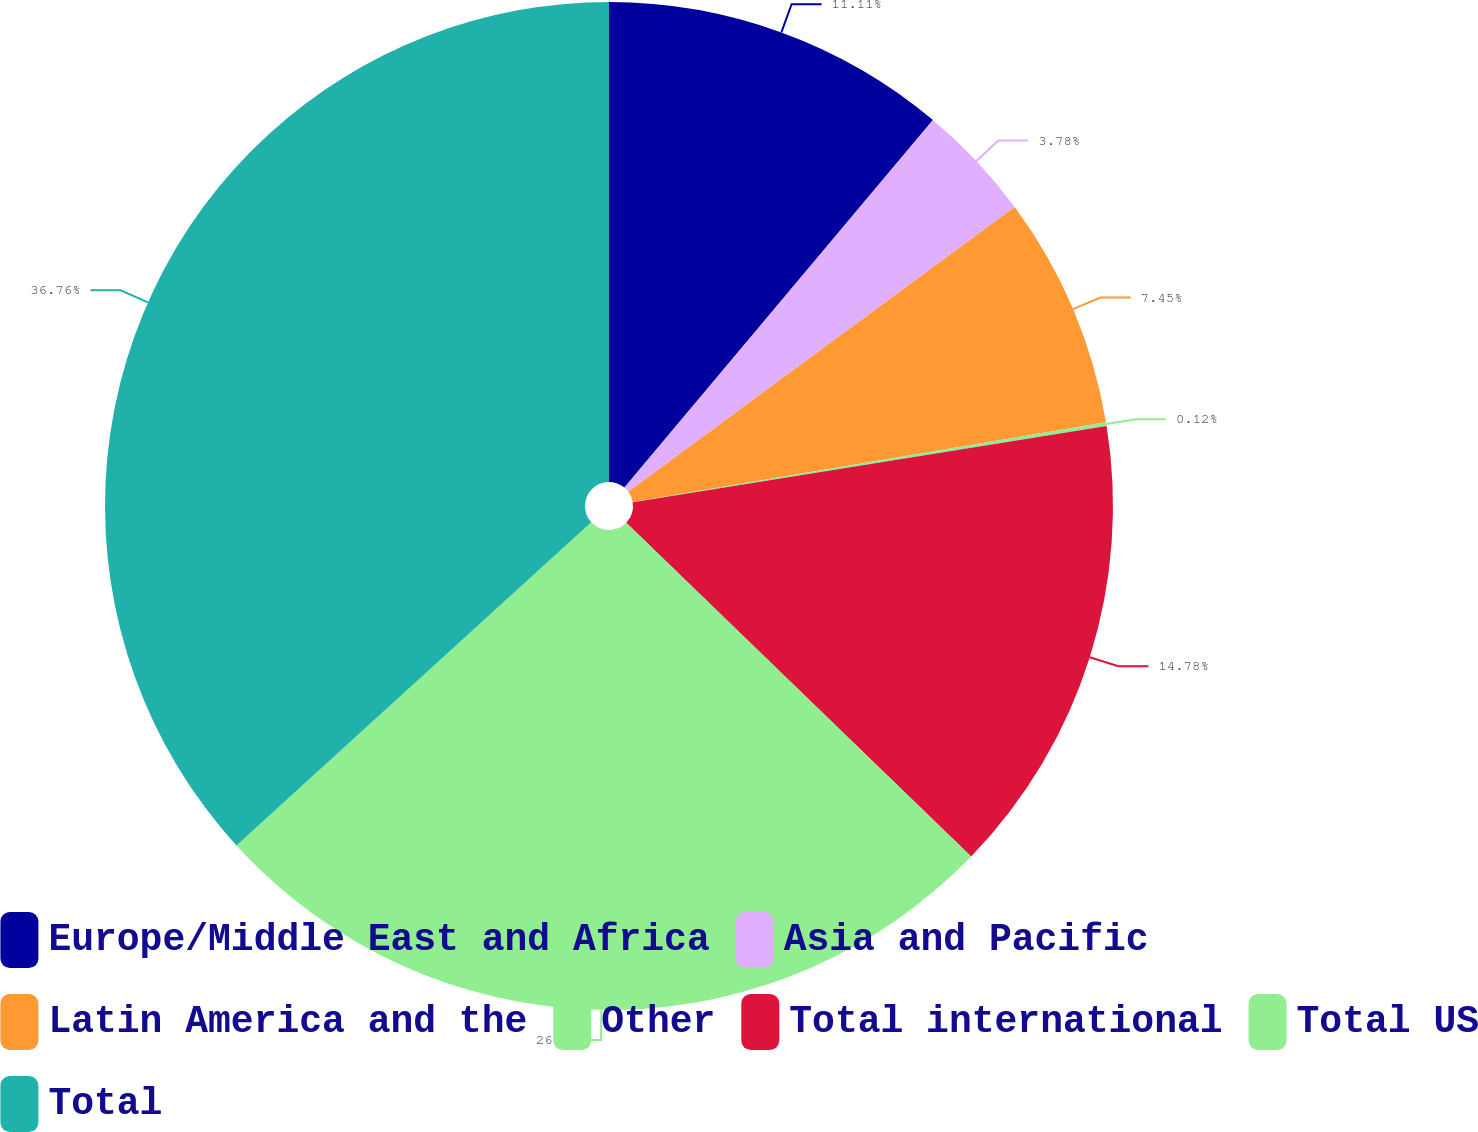Convert chart. <chart><loc_0><loc_0><loc_500><loc_500><pie_chart><fcel>Europe/Middle East and Africa<fcel>Asia and Pacific<fcel>Latin America and the<fcel>Other<fcel>Total international<fcel>Total US<fcel>Total<nl><fcel>11.11%<fcel>3.78%<fcel>7.45%<fcel>0.12%<fcel>14.78%<fcel>26.0%<fcel>36.76%<nl></chart> 